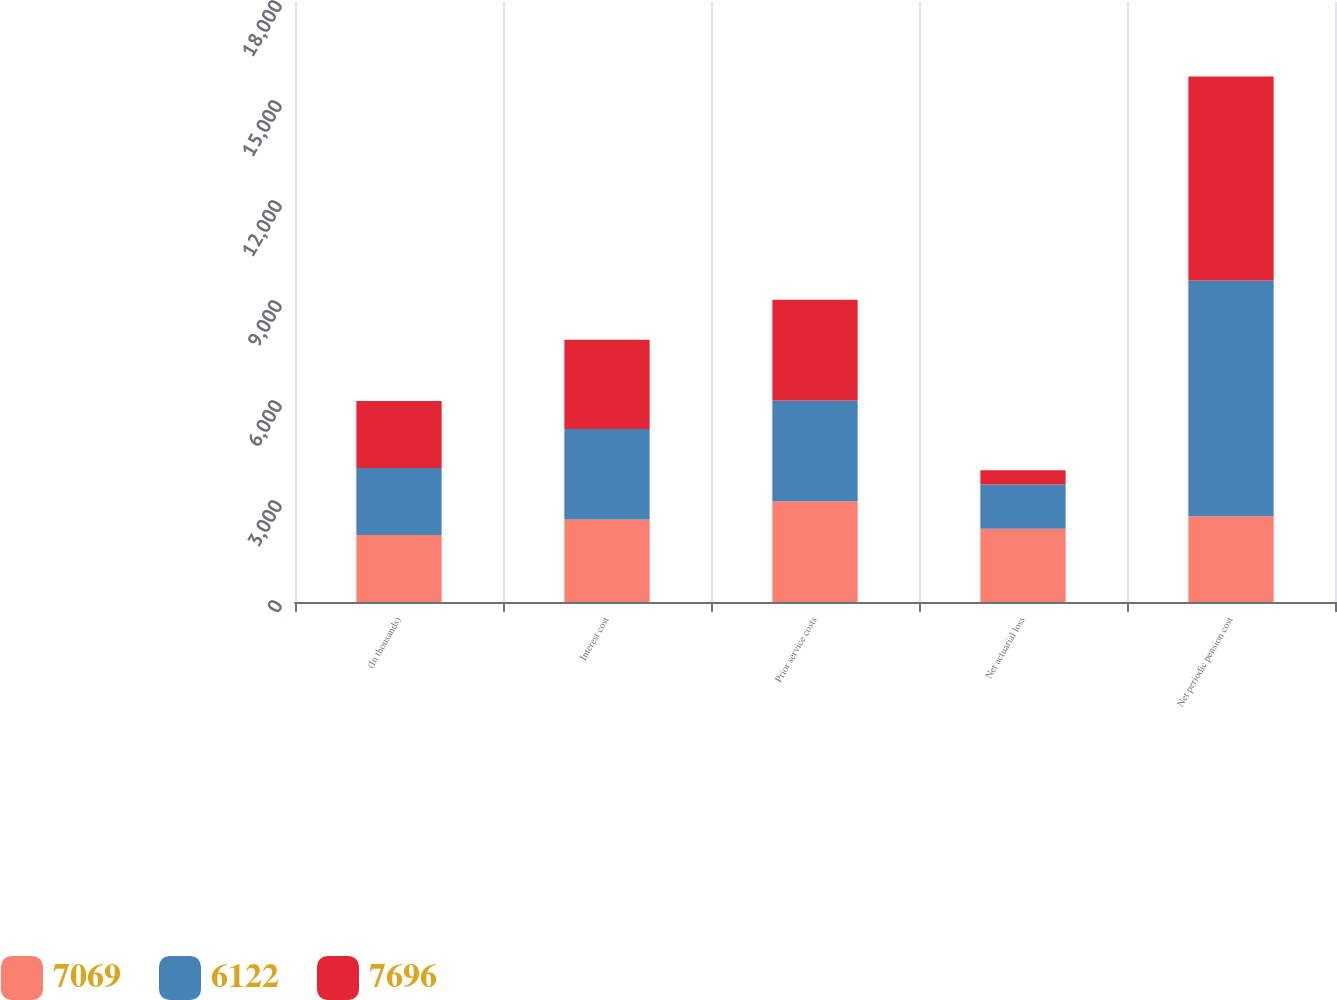Convert chart to OTSL. <chart><loc_0><loc_0><loc_500><loc_500><stacked_bar_chart><ecel><fcel>(In thousands)<fcel>Interest cost<fcel>Prior service costs<fcel>Net actuarial loss<fcel>Net periodic pension cost<nl><fcel>7069<fcel>2012<fcel>2476<fcel>3023<fcel>2197<fcel>2575.5<nl><fcel>6122<fcel>2011<fcel>2716<fcel>3023<fcel>1330<fcel>7069<nl><fcel>7696<fcel>2010<fcel>2675<fcel>3023<fcel>424<fcel>6122<nl></chart> 